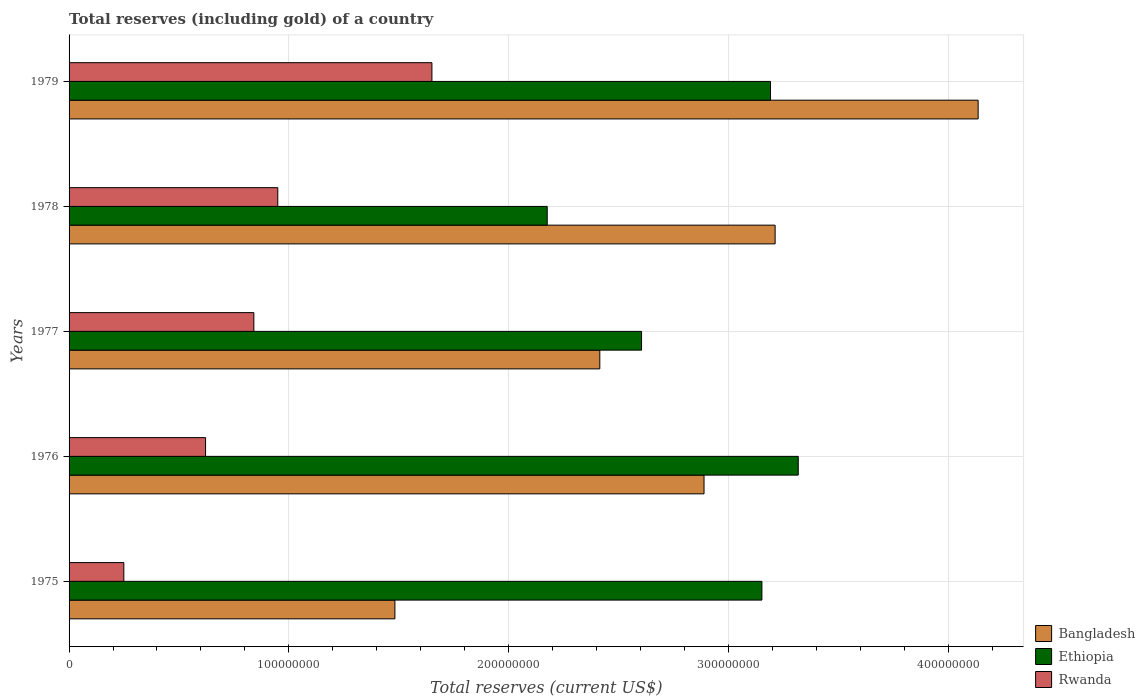How many different coloured bars are there?
Offer a terse response. 3. Are the number of bars on each tick of the Y-axis equal?
Your answer should be compact. Yes. What is the label of the 1st group of bars from the top?
Ensure brevity in your answer.  1979. What is the total reserves (including gold) in Rwanda in 1979?
Provide a short and direct response. 1.65e+08. Across all years, what is the maximum total reserves (including gold) in Rwanda?
Your answer should be compact. 1.65e+08. Across all years, what is the minimum total reserves (including gold) in Bangladesh?
Give a very brief answer. 1.48e+08. In which year was the total reserves (including gold) in Bangladesh maximum?
Offer a very short reply. 1979. In which year was the total reserves (including gold) in Bangladesh minimum?
Offer a terse response. 1975. What is the total total reserves (including gold) in Rwanda in the graph?
Ensure brevity in your answer.  4.31e+08. What is the difference between the total reserves (including gold) in Ethiopia in 1975 and that in 1978?
Make the answer very short. 9.77e+07. What is the difference between the total reserves (including gold) in Bangladesh in 1977 and the total reserves (including gold) in Rwanda in 1975?
Your answer should be very brief. 2.17e+08. What is the average total reserves (including gold) in Rwanda per year?
Provide a succinct answer. 8.62e+07. In the year 1977, what is the difference between the total reserves (including gold) in Bangladesh and total reserves (including gold) in Ethiopia?
Ensure brevity in your answer.  -1.90e+07. In how many years, is the total reserves (including gold) in Bangladesh greater than 120000000 US$?
Ensure brevity in your answer.  5. What is the ratio of the total reserves (including gold) in Rwanda in 1977 to that in 1978?
Offer a very short reply. 0.89. Is the total reserves (including gold) in Ethiopia in 1975 less than that in 1976?
Your answer should be very brief. Yes. What is the difference between the highest and the second highest total reserves (including gold) in Rwanda?
Keep it short and to the point. 7.01e+07. What is the difference between the highest and the lowest total reserves (including gold) in Bangladesh?
Make the answer very short. 2.65e+08. Is the sum of the total reserves (including gold) in Rwanda in 1978 and 1979 greater than the maximum total reserves (including gold) in Bangladesh across all years?
Your response must be concise. No. What does the 1st bar from the top in 1976 represents?
Your response must be concise. Rwanda. What does the 2nd bar from the bottom in 1978 represents?
Offer a very short reply. Ethiopia. How many bars are there?
Provide a short and direct response. 15. What is the difference between two consecutive major ticks on the X-axis?
Make the answer very short. 1.00e+08. Does the graph contain any zero values?
Offer a very short reply. No. How many legend labels are there?
Offer a terse response. 3. How are the legend labels stacked?
Give a very brief answer. Vertical. What is the title of the graph?
Keep it short and to the point. Total reserves (including gold) of a country. What is the label or title of the X-axis?
Your answer should be compact. Total reserves (current US$). What is the label or title of the Y-axis?
Your answer should be compact. Years. What is the Total reserves (current US$) of Bangladesh in 1975?
Your answer should be very brief. 1.48e+08. What is the Total reserves (current US$) in Ethiopia in 1975?
Offer a very short reply. 3.15e+08. What is the Total reserves (current US$) of Rwanda in 1975?
Keep it short and to the point. 2.49e+07. What is the Total reserves (current US$) in Bangladesh in 1976?
Offer a very short reply. 2.89e+08. What is the Total reserves (current US$) in Ethiopia in 1976?
Keep it short and to the point. 3.32e+08. What is the Total reserves (current US$) of Rwanda in 1976?
Give a very brief answer. 6.21e+07. What is the Total reserves (current US$) of Bangladesh in 1977?
Offer a very short reply. 2.41e+08. What is the Total reserves (current US$) in Ethiopia in 1977?
Your response must be concise. 2.60e+08. What is the Total reserves (current US$) of Rwanda in 1977?
Give a very brief answer. 8.41e+07. What is the Total reserves (current US$) in Bangladesh in 1978?
Provide a succinct answer. 3.21e+08. What is the Total reserves (current US$) in Ethiopia in 1978?
Provide a short and direct response. 2.18e+08. What is the Total reserves (current US$) in Rwanda in 1978?
Your answer should be compact. 9.50e+07. What is the Total reserves (current US$) in Bangladesh in 1979?
Offer a terse response. 4.14e+08. What is the Total reserves (current US$) of Ethiopia in 1979?
Provide a short and direct response. 3.19e+08. What is the Total reserves (current US$) of Rwanda in 1979?
Your answer should be very brief. 1.65e+08. Across all years, what is the maximum Total reserves (current US$) of Bangladesh?
Give a very brief answer. 4.14e+08. Across all years, what is the maximum Total reserves (current US$) in Ethiopia?
Ensure brevity in your answer.  3.32e+08. Across all years, what is the maximum Total reserves (current US$) in Rwanda?
Offer a terse response. 1.65e+08. Across all years, what is the minimum Total reserves (current US$) in Bangladesh?
Provide a succinct answer. 1.48e+08. Across all years, what is the minimum Total reserves (current US$) in Ethiopia?
Ensure brevity in your answer.  2.18e+08. Across all years, what is the minimum Total reserves (current US$) of Rwanda?
Provide a short and direct response. 2.49e+07. What is the total Total reserves (current US$) in Bangladesh in the graph?
Keep it short and to the point. 1.41e+09. What is the total Total reserves (current US$) in Ethiopia in the graph?
Your answer should be compact. 1.44e+09. What is the total Total reserves (current US$) of Rwanda in the graph?
Keep it short and to the point. 4.31e+08. What is the difference between the Total reserves (current US$) in Bangladesh in 1975 and that in 1976?
Your answer should be very brief. -1.41e+08. What is the difference between the Total reserves (current US$) in Ethiopia in 1975 and that in 1976?
Provide a short and direct response. -1.65e+07. What is the difference between the Total reserves (current US$) in Rwanda in 1975 and that in 1976?
Your answer should be very brief. -3.72e+07. What is the difference between the Total reserves (current US$) of Bangladesh in 1975 and that in 1977?
Offer a very short reply. -9.32e+07. What is the difference between the Total reserves (current US$) of Ethiopia in 1975 and that in 1977?
Offer a very short reply. 5.48e+07. What is the difference between the Total reserves (current US$) of Rwanda in 1975 and that in 1977?
Offer a very short reply. -5.92e+07. What is the difference between the Total reserves (current US$) of Bangladesh in 1975 and that in 1978?
Offer a terse response. -1.73e+08. What is the difference between the Total reserves (current US$) in Ethiopia in 1975 and that in 1978?
Give a very brief answer. 9.77e+07. What is the difference between the Total reserves (current US$) of Rwanda in 1975 and that in 1978?
Provide a short and direct response. -7.01e+07. What is the difference between the Total reserves (current US$) of Bangladesh in 1975 and that in 1979?
Keep it short and to the point. -2.65e+08. What is the difference between the Total reserves (current US$) of Ethiopia in 1975 and that in 1979?
Your response must be concise. -3.91e+06. What is the difference between the Total reserves (current US$) in Rwanda in 1975 and that in 1979?
Make the answer very short. -1.40e+08. What is the difference between the Total reserves (current US$) of Bangladesh in 1976 and that in 1977?
Make the answer very short. 4.74e+07. What is the difference between the Total reserves (current US$) in Ethiopia in 1976 and that in 1977?
Provide a succinct answer. 7.13e+07. What is the difference between the Total reserves (current US$) in Rwanda in 1976 and that in 1977?
Offer a very short reply. -2.20e+07. What is the difference between the Total reserves (current US$) in Bangladesh in 1976 and that in 1978?
Your answer should be compact. -3.23e+07. What is the difference between the Total reserves (current US$) of Ethiopia in 1976 and that in 1978?
Your response must be concise. 1.14e+08. What is the difference between the Total reserves (current US$) in Rwanda in 1976 and that in 1978?
Your answer should be compact. -3.29e+07. What is the difference between the Total reserves (current US$) of Bangladesh in 1976 and that in 1979?
Offer a terse response. -1.25e+08. What is the difference between the Total reserves (current US$) of Ethiopia in 1976 and that in 1979?
Provide a succinct answer. 1.26e+07. What is the difference between the Total reserves (current US$) of Rwanda in 1976 and that in 1979?
Give a very brief answer. -1.03e+08. What is the difference between the Total reserves (current US$) in Bangladesh in 1977 and that in 1978?
Offer a terse response. -7.98e+07. What is the difference between the Total reserves (current US$) in Ethiopia in 1977 and that in 1978?
Provide a short and direct response. 4.29e+07. What is the difference between the Total reserves (current US$) in Rwanda in 1977 and that in 1978?
Offer a terse response. -1.09e+07. What is the difference between the Total reserves (current US$) in Bangladesh in 1977 and that in 1979?
Provide a succinct answer. -1.72e+08. What is the difference between the Total reserves (current US$) in Ethiopia in 1977 and that in 1979?
Ensure brevity in your answer.  -5.87e+07. What is the difference between the Total reserves (current US$) of Rwanda in 1977 and that in 1979?
Provide a succinct answer. -8.10e+07. What is the difference between the Total reserves (current US$) in Bangladesh in 1978 and that in 1979?
Give a very brief answer. -9.24e+07. What is the difference between the Total reserves (current US$) of Ethiopia in 1978 and that in 1979?
Make the answer very short. -1.02e+08. What is the difference between the Total reserves (current US$) of Rwanda in 1978 and that in 1979?
Ensure brevity in your answer.  -7.01e+07. What is the difference between the Total reserves (current US$) in Bangladesh in 1975 and the Total reserves (current US$) in Ethiopia in 1976?
Keep it short and to the point. -1.84e+08. What is the difference between the Total reserves (current US$) of Bangladesh in 1975 and the Total reserves (current US$) of Rwanda in 1976?
Your answer should be very brief. 8.62e+07. What is the difference between the Total reserves (current US$) of Ethiopia in 1975 and the Total reserves (current US$) of Rwanda in 1976?
Provide a succinct answer. 2.53e+08. What is the difference between the Total reserves (current US$) in Bangladesh in 1975 and the Total reserves (current US$) in Ethiopia in 1977?
Keep it short and to the point. -1.12e+08. What is the difference between the Total reserves (current US$) of Bangladesh in 1975 and the Total reserves (current US$) of Rwanda in 1977?
Give a very brief answer. 6.42e+07. What is the difference between the Total reserves (current US$) of Ethiopia in 1975 and the Total reserves (current US$) of Rwanda in 1977?
Provide a succinct answer. 2.31e+08. What is the difference between the Total reserves (current US$) of Bangladesh in 1975 and the Total reserves (current US$) of Ethiopia in 1978?
Ensure brevity in your answer.  -6.93e+07. What is the difference between the Total reserves (current US$) in Bangladesh in 1975 and the Total reserves (current US$) in Rwanda in 1978?
Give a very brief answer. 5.33e+07. What is the difference between the Total reserves (current US$) in Ethiopia in 1975 and the Total reserves (current US$) in Rwanda in 1978?
Keep it short and to the point. 2.20e+08. What is the difference between the Total reserves (current US$) in Bangladesh in 1975 and the Total reserves (current US$) in Ethiopia in 1979?
Your response must be concise. -1.71e+08. What is the difference between the Total reserves (current US$) of Bangladesh in 1975 and the Total reserves (current US$) of Rwanda in 1979?
Offer a terse response. -1.68e+07. What is the difference between the Total reserves (current US$) in Ethiopia in 1975 and the Total reserves (current US$) in Rwanda in 1979?
Make the answer very short. 1.50e+08. What is the difference between the Total reserves (current US$) in Bangladesh in 1976 and the Total reserves (current US$) in Ethiopia in 1977?
Offer a very short reply. 2.84e+07. What is the difference between the Total reserves (current US$) of Bangladesh in 1976 and the Total reserves (current US$) of Rwanda in 1977?
Keep it short and to the point. 2.05e+08. What is the difference between the Total reserves (current US$) in Ethiopia in 1976 and the Total reserves (current US$) in Rwanda in 1977?
Your answer should be very brief. 2.48e+08. What is the difference between the Total reserves (current US$) in Bangladesh in 1976 and the Total reserves (current US$) in Ethiopia in 1978?
Provide a short and direct response. 7.14e+07. What is the difference between the Total reserves (current US$) in Bangladesh in 1976 and the Total reserves (current US$) in Rwanda in 1978?
Your response must be concise. 1.94e+08. What is the difference between the Total reserves (current US$) of Ethiopia in 1976 and the Total reserves (current US$) of Rwanda in 1978?
Give a very brief answer. 2.37e+08. What is the difference between the Total reserves (current US$) of Bangladesh in 1976 and the Total reserves (current US$) of Ethiopia in 1979?
Offer a very short reply. -3.02e+07. What is the difference between the Total reserves (current US$) of Bangladesh in 1976 and the Total reserves (current US$) of Rwanda in 1979?
Your answer should be very brief. 1.24e+08. What is the difference between the Total reserves (current US$) of Ethiopia in 1976 and the Total reserves (current US$) of Rwanda in 1979?
Provide a short and direct response. 1.67e+08. What is the difference between the Total reserves (current US$) in Bangladesh in 1977 and the Total reserves (current US$) in Ethiopia in 1978?
Ensure brevity in your answer.  2.39e+07. What is the difference between the Total reserves (current US$) of Bangladesh in 1977 and the Total reserves (current US$) of Rwanda in 1978?
Keep it short and to the point. 1.47e+08. What is the difference between the Total reserves (current US$) in Ethiopia in 1977 and the Total reserves (current US$) in Rwanda in 1978?
Your response must be concise. 1.66e+08. What is the difference between the Total reserves (current US$) of Bangladesh in 1977 and the Total reserves (current US$) of Ethiopia in 1979?
Provide a short and direct response. -7.77e+07. What is the difference between the Total reserves (current US$) in Bangladesh in 1977 and the Total reserves (current US$) in Rwanda in 1979?
Your answer should be very brief. 7.64e+07. What is the difference between the Total reserves (current US$) of Ethiopia in 1977 and the Total reserves (current US$) of Rwanda in 1979?
Make the answer very short. 9.54e+07. What is the difference between the Total reserves (current US$) of Bangladesh in 1978 and the Total reserves (current US$) of Ethiopia in 1979?
Offer a very short reply. 2.11e+06. What is the difference between the Total reserves (current US$) in Bangladesh in 1978 and the Total reserves (current US$) in Rwanda in 1979?
Keep it short and to the point. 1.56e+08. What is the difference between the Total reserves (current US$) in Ethiopia in 1978 and the Total reserves (current US$) in Rwanda in 1979?
Your response must be concise. 5.25e+07. What is the average Total reserves (current US$) of Bangladesh per year?
Offer a terse response. 2.83e+08. What is the average Total reserves (current US$) in Ethiopia per year?
Make the answer very short. 2.89e+08. What is the average Total reserves (current US$) in Rwanda per year?
Your answer should be very brief. 8.62e+07. In the year 1975, what is the difference between the Total reserves (current US$) in Bangladesh and Total reserves (current US$) in Ethiopia?
Your answer should be compact. -1.67e+08. In the year 1975, what is the difference between the Total reserves (current US$) of Bangladesh and Total reserves (current US$) of Rwanda?
Give a very brief answer. 1.23e+08. In the year 1975, what is the difference between the Total reserves (current US$) of Ethiopia and Total reserves (current US$) of Rwanda?
Make the answer very short. 2.90e+08. In the year 1976, what is the difference between the Total reserves (current US$) of Bangladesh and Total reserves (current US$) of Ethiopia?
Provide a succinct answer. -4.29e+07. In the year 1976, what is the difference between the Total reserves (current US$) of Bangladesh and Total reserves (current US$) of Rwanda?
Offer a very short reply. 2.27e+08. In the year 1976, what is the difference between the Total reserves (current US$) in Ethiopia and Total reserves (current US$) in Rwanda?
Keep it short and to the point. 2.70e+08. In the year 1977, what is the difference between the Total reserves (current US$) in Bangladesh and Total reserves (current US$) in Ethiopia?
Offer a terse response. -1.90e+07. In the year 1977, what is the difference between the Total reserves (current US$) in Bangladesh and Total reserves (current US$) in Rwanda?
Ensure brevity in your answer.  1.57e+08. In the year 1977, what is the difference between the Total reserves (current US$) of Ethiopia and Total reserves (current US$) of Rwanda?
Offer a very short reply. 1.76e+08. In the year 1978, what is the difference between the Total reserves (current US$) of Bangladesh and Total reserves (current US$) of Ethiopia?
Ensure brevity in your answer.  1.04e+08. In the year 1978, what is the difference between the Total reserves (current US$) of Bangladesh and Total reserves (current US$) of Rwanda?
Offer a very short reply. 2.26e+08. In the year 1978, what is the difference between the Total reserves (current US$) of Ethiopia and Total reserves (current US$) of Rwanda?
Offer a very short reply. 1.23e+08. In the year 1979, what is the difference between the Total reserves (current US$) in Bangladesh and Total reserves (current US$) in Ethiopia?
Provide a succinct answer. 9.45e+07. In the year 1979, what is the difference between the Total reserves (current US$) of Bangladesh and Total reserves (current US$) of Rwanda?
Give a very brief answer. 2.49e+08. In the year 1979, what is the difference between the Total reserves (current US$) of Ethiopia and Total reserves (current US$) of Rwanda?
Provide a short and direct response. 1.54e+08. What is the ratio of the Total reserves (current US$) of Bangladesh in 1975 to that in 1976?
Offer a terse response. 0.51. What is the ratio of the Total reserves (current US$) in Ethiopia in 1975 to that in 1976?
Provide a succinct answer. 0.95. What is the ratio of the Total reserves (current US$) of Rwanda in 1975 to that in 1976?
Make the answer very short. 0.4. What is the ratio of the Total reserves (current US$) in Bangladesh in 1975 to that in 1977?
Provide a succinct answer. 0.61. What is the ratio of the Total reserves (current US$) of Ethiopia in 1975 to that in 1977?
Your answer should be very brief. 1.21. What is the ratio of the Total reserves (current US$) of Rwanda in 1975 to that in 1977?
Offer a terse response. 0.3. What is the ratio of the Total reserves (current US$) in Bangladesh in 1975 to that in 1978?
Keep it short and to the point. 0.46. What is the ratio of the Total reserves (current US$) in Ethiopia in 1975 to that in 1978?
Provide a succinct answer. 1.45. What is the ratio of the Total reserves (current US$) of Rwanda in 1975 to that in 1978?
Keep it short and to the point. 0.26. What is the ratio of the Total reserves (current US$) in Bangladesh in 1975 to that in 1979?
Offer a very short reply. 0.36. What is the ratio of the Total reserves (current US$) in Rwanda in 1975 to that in 1979?
Provide a short and direct response. 0.15. What is the ratio of the Total reserves (current US$) in Bangladesh in 1976 to that in 1977?
Give a very brief answer. 1.2. What is the ratio of the Total reserves (current US$) of Ethiopia in 1976 to that in 1977?
Keep it short and to the point. 1.27. What is the ratio of the Total reserves (current US$) of Rwanda in 1976 to that in 1977?
Keep it short and to the point. 0.74. What is the ratio of the Total reserves (current US$) in Bangladesh in 1976 to that in 1978?
Give a very brief answer. 0.9. What is the ratio of the Total reserves (current US$) of Ethiopia in 1976 to that in 1978?
Your answer should be very brief. 1.52. What is the ratio of the Total reserves (current US$) in Rwanda in 1976 to that in 1978?
Your response must be concise. 0.65. What is the ratio of the Total reserves (current US$) of Bangladesh in 1976 to that in 1979?
Your response must be concise. 0.7. What is the ratio of the Total reserves (current US$) in Ethiopia in 1976 to that in 1979?
Keep it short and to the point. 1.04. What is the ratio of the Total reserves (current US$) of Rwanda in 1976 to that in 1979?
Give a very brief answer. 0.38. What is the ratio of the Total reserves (current US$) of Bangladesh in 1977 to that in 1978?
Offer a very short reply. 0.75. What is the ratio of the Total reserves (current US$) of Ethiopia in 1977 to that in 1978?
Give a very brief answer. 1.2. What is the ratio of the Total reserves (current US$) of Rwanda in 1977 to that in 1978?
Provide a succinct answer. 0.89. What is the ratio of the Total reserves (current US$) of Bangladesh in 1977 to that in 1979?
Your response must be concise. 0.58. What is the ratio of the Total reserves (current US$) of Ethiopia in 1977 to that in 1979?
Offer a very short reply. 0.82. What is the ratio of the Total reserves (current US$) in Rwanda in 1977 to that in 1979?
Offer a terse response. 0.51. What is the ratio of the Total reserves (current US$) of Bangladesh in 1978 to that in 1979?
Offer a very short reply. 0.78. What is the ratio of the Total reserves (current US$) in Ethiopia in 1978 to that in 1979?
Offer a terse response. 0.68. What is the ratio of the Total reserves (current US$) in Rwanda in 1978 to that in 1979?
Keep it short and to the point. 0.58. What is the difference between the highest and the second highest Total reserves (current US$) in Bangladesh?
Your response must be concise. 9.24e+07. What is the difference between the highest and the second highest Total reserves (current US$) in Ethiopia?
Your response must be concise. 1.26e+07. What is the difference between the highest and the second highest Total reserves (current US$) in Rwanda?
Offer a very short reply. 7.01e+07. What is the difference between the highest and the lowest Total reserves (current US$) in Bangladesh?
Make the answer very short. 2.65e+08. What is the difference between the highest and the lowest Total reserves (current US$) in Ethiopia?
Your answer should be compact. 1.14e+08. What is the difference between the highest and the lowest Total reserves (current US$) of Rwanda?
Give a very brief answer. 1.40e+08. 